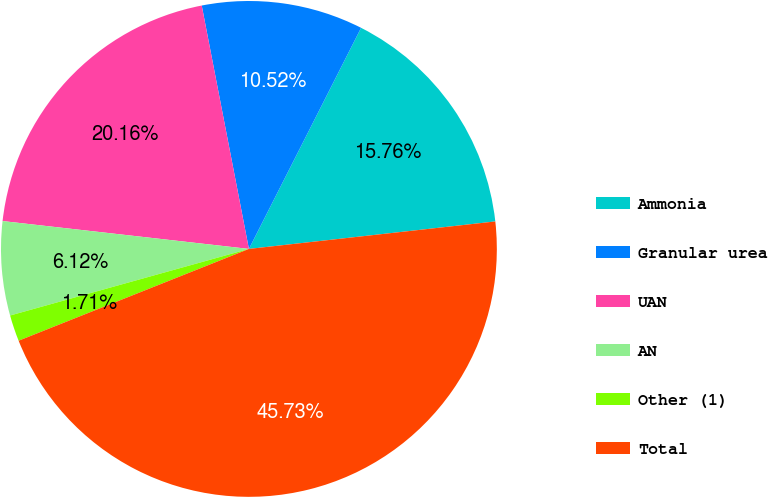<chart> <loc_0><loc_0><loc_500><loc_500><pie_chart><fcel>Ammonia<fcel>Granular urea<fcel>UAN<fcel>AN<fcel>Other (1)<fcel>Total<nl><fcel>15.76%<fcel>10.52%<fcel>20.16%<fcel>6.12%<fcel>1.71%<fcel>45.73%<nl></chart> 